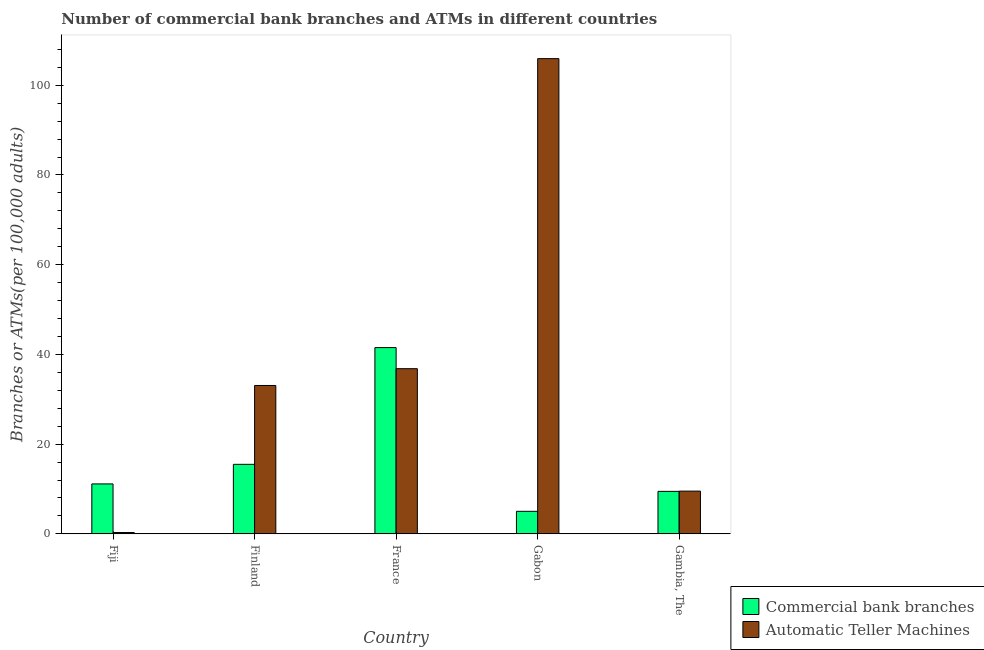How many different coloured bars are there?
Your response must be concise. 2. Are the number of bars on each tick of the X-axis equal?
Your response must be concise. Yes. How many bars are there on the 4th tick from the right?
Offer a very short reply. 2. In how many cases, is the number of bars for a given country not equal to the number of legend labels?
Your answer should be very brief. 0. What is the number of commercal bank branches in Gabon?
Offer a terse response. 5.03. Across all countries, what is the maximum number of atms?
Ensure brevity in your answer.  105.94. Across all countries, what is the minimum number of atms?
Your response must be concise. 0.3. In which country was the number of commercal bank branches minimum?
Provide a succinct answer. Gabon. What is the total number of commercal bank branches in the graph?
Your response must be concise. 82.66. What is the difference between the number of commercal bank branches in Gabon and that in Gambia, The?
Offer a terse response. -4.45. What is the difference between the number of commercal bank branches in Fiji and the number of atms in France?
Make the answer very short. -25.69. What is the average number of atms per country?
Ensure brevity in your answer.  37.13. What is the difference between the number of commercal bank branches and number of atms in Gabon?
Give a very brief answer. -100.91. What is the ratio of the number of atms in Finland to that in Gabon?
Make the answer very short. 0.31. Is the number of commercal bank branches in Fiji less than that in France?
Offer a terse response. Yes. What is the difference between the highest and the second highest number of commercal bank branches?
Provide a succinct answer. 26.03. What is the difference between the highest and the lowest number of atms?
Your answer should be compact. 105.64. Is the sum of the number of atms in Fiji and Gabon greater than the maximum number of commercal bank branches across all countries?
Provide a short and direct response. Yes. What does the 2nd bar from the left in Finland represents?
Your answer should be compact. Automatic Teller Machines. What does the 2nd bar from the right in Finland represents?
Offer a very short reply. Commercial bank branches. How many countries are there in the graph?
Make the answer very short. 5. What is the difference between two consecutive major ticks on the Y-axis?
Give a very brief answer. 20. Are the values on the major ticks of Y-axis written in scientific E-notation?
Provide a short and direct response. No. Does the graph contain any zero values?
Make the answer very short. No. Does the graph contain grids?
Make the answer very short. No. Where does the legend appear in the graph?
Your response must be concise. Bottom right. How many legend labels are there?
Provide a short and direct response. 2. What is the title of the graph?
Offer a very short reply. Number of commercial bank branches and ATMs in different countries. Does "% of GNI" appear as one of the legend labels in the graph?
Provide a succinct answer. No. What is the label or title of the Y-axis?
Keep it short and to the point. Branches or ATMs(per 100,0 adults). What is the Branches or ATMs(per 100,000 adults) in Commercial bank branches in Fiji?
Offer a very short reply. 11.14. What is the Branches or ATMs(per 100,000 adults) of Automatic Teller Machines in Fiji?
Offer a very short reply. 0.3. What is the Branches or ATMs(per 100,000 adults) in Commercial bank branches in Finland?
Ensure brevity in your answer.  15.5. What is the Branches or ATMs(per 100,000 adults) of Automatic Teller Machines in Finland?
Your answer should be compact. 33.08. What is the Branches or ATMs(per 100,000 adults) of Commercial bank branches in France?
Your response must be concise. 41.52. What is the Branches or ATMs(per 100,000 adults) in Automatic Teller Machines in France?
Offer a very short reply. 36.82. What is the Branches or ATMs(per 100,000 adults) in Commercial bank branches in Gabon?
Provide a succinct answer. 5.03. What is the Branches or ATMs(per 100,000 adults) of Automatic Teller Machines in Gabon?
Give a very brief answer. 105.94. What is the Branches or ATMs(per 100,000 adults) of Commercial bank branches in Gambia, The?
Provide a succinct answer. 9.47. What is the Branches or ATMs(per 100,000 adults) in Automatic Teller Machines in Gambia, The?
Make the answer very short. 9.53. Across all countries, what is the maximum Branches or ATMs(per 100,000 adults) of Commercial bank branches?
Your response must be concise. 41.52. Across all countries, what is the maximum Branches or ATMs(per 100,000 adults) of Automatic Teller Machines?
Make the answer very short. 105.94. Across all countries, what is the minimum Branches or ATMs(per 100,000 adults) in Commercial bank branches?
Offer a very short reply. 5.03. Across all countries, what is the minimum Branches or ATMs(per 100,000 adults) of Automatic Teller Machines?
Give a very brief answer. 0.3. What is the total Branches or ATMs(per 100,000 adults) of Commercial bank branches in the graph?
Offer a terse response. 82.66. What is the total Branches or ATMs(per 100,000 adults) in Automatic Teller Machines in the graph?
Give a very brief answer. 185.67. What is the difference between the Branches or ATMs(per 100,000 adults) of Commercial bank branches in Fiji and that in Finland?
Ensure brevity in your answer.  -4.36. What is the difference between the Branches or ATMs(per 100,000 adults) in Automatic Teller Machines in Fiji and that in Finland?
Provide a succinct answer. -32.78. What is the difference between the Branches or ATMs(per 100,000 adults) in Commercial bank branches in Fiji and that in France?
Offer a terse response. -30.39. What is the difference between the Branches or ATMs(per 100,000 adults) of Automatic Teller Machines in Fiji and that in France?
Your answer should be very brief. -36.52. What is the difference between the Branches or ATMs(per 100,000 adults) in Commercial bank branches in Fiji and that in Gabon?
Offer a very short reply. 6.11. What is the difference between the Branches or ATMs(per 100,000 adults) of Automatic Teller Machines in Fiji and that in Gabon?
Keep it short and to the point. -105.64. What is the difference between the Branches or ATMs(per 100,000 adults) of Commercial bank branches in Fiji and that in Gambia, The?
Offer a terse response. 1.66. What is the difference between the Branches or ATMs(per 100,000 adults) in Automatic Teller Machines in Fiji and that in Gambia, The?
Offer a terse response. -9.23. What is the difference between the Branches or ATMs(per 100,000 adults) of Commercial bank branches in Finland and that in France?
Provide a succinct answer. -26.03. What is the difference between the Branches or ATMs(per 100,000 adults) in Automatic Teller Machines in Finland and that in France?
Make the answer very short. -3.75. What is the difference between the Branches or ATMs(per 100,000 adults) in Commercial bank branches in Finland and that in Gabon?
Keep it short and to the point. 10.47. What is the difference between the Branches or ATMs(per 100,000 adults) in Automatic Teller Machines in Finland and that in Gabon?
Your response must be concise. -72.86. What is the difference between the Branches or ATMs(per 100,000 adults) of Commercial bank branches in Finland and that in Gambia, The?
Offer a very short reply. 6.03. What is the difference between the Branches or ATMs(per 100,000 adults) of Automatic Teller Machines in Finland and that in Gambia, The?
Keep it short and to the point. 23.55. What is the difference between the Branches or ATMs(per 100,000 adults) of Commercial bank branches in France and that in Gabon?
Your answer should be compact. 36.5. What is the difference between the Branches or ATMs(per 100,000 adults) in Automatic Teller Machines in France and that in Gabon?
Provide a succinct answer. -69.12. What is the difference between the Branches or ATMs(per 100,000 adults) of Commercial bank branches in France and that in Gambia, The?
Provide a short and direct response. 32.05. What is the difference between the Branches or ATMs(per 100,000 adults) of Automatic Teller Machines in France and that in Gambia, The?
Your answer should be very brief. 27.3. What is the difference between the Branches or ATMs(per 100,000 adults) of Commercial bank branches in Gabon and that in Gambia, The?
Offer a very short reply. -4.45. What is the difference between the Branches or ATMs(per 100,000 adults) in Automatic Teller Machines in Gabon and that in Gambia, The?
Your answer should be very brief. 96.41. What is the difference between the Branches or ATMs(per 100,000 adults) in Commercial bank branches in Fiji and the Branches or ATMs(per 100,000 adults) in Automatic Teller Machines in Finland?
Keep it short and to the point. -21.94. What is the difference between the Branches or ATMs(per 100,000 adults) of Commercial bank branches in Fiji and the Branches or ATMs(per 100,000 adults) of Automatic Teller Machines in France?
Make the answer very short. -25.69. What is the difference between the Branches or ATMs(per 100,000 adults) in Commercial bank branches in Fiji and the Branches or ATMs(per 100,000 adults) in Automatic Teller Machines in Gabon?
Provide a short and direct response. -94.81. What is the difference between the Branches or ATMs(per 100,000 adults) in Commercial bank branches in Fiji and the Branches or ATMs(per 100,000 adults) in Automatic Teller Machines in Gambia, The?
Provide a short and direct response. 1.61. What is the difference between the Branches or ATMs(per 100,000 adults) in Commercial bank branches in Finland and the Branches or ATMs(per 100,000 adults) in Automatic Teller Machines in France?
Give a very brief answer. -21.33. What is the difference between the Branches or ATMs(per 100,000 adults) of Commercial bank branches in Finland and the Branches or ATMs(per 100,000 adults) of Automatic Teller Machines in Gabon?
Offer a terse response. -90.44. What is the difference between the Branches or ATMs(per 100,000 adults) of Commercial bank branches in Finland and the Branches or ATMs(per 100,000 adults) of Automatic Teller Machines in Gambia, The?
Offer a terse response. 5.97. What is the difference between the Branches or ATMs(per 100,000 adults) of Commercial bank branches in France and the Branches or ATMs(per 100,000 adults) of Automatic Teller Machines in Gabon?
Your response must be concise. -64.42. What is the difference between the Branches or ATMs(per 100,000 adults) in Commercial bank branches in France and the Branches or ATMs(per 100,000 adults) in Automatic Teller Machines in Gambia, The?
Keep it short and to the point. 32. What is the difference between the Branches or ATMs(per 100,000 adults) of Commercial bank branches in Gabon and the Branches or ATMs(per 100,000 adults) of Automatic Teller Machines in Gambia, The?
Provide a short and direct response. -4.5. What is the average Branches or ATMs(per 100,000 adults) in Commercial bank branches per country?
Offer a terse response. 16.53. What is the average Branches or ATMs(per 100,000 adults) of Automatic Teller Machines per country?
Provide a short and direct response. 37.13. What is the difference between the Branches or ATMs(per 100,000 adults) in Commercial bank branches and Branches or ATMs(per 100,000 adults) in Automatic Teller Machines in Fiji?
Provide a short and direct response. 10.84. What is the difference between the Branches or ATMs(per 100,000 adults) in Commercial bank branches and Branches or ATMs(per 100,000 adults) in Automatic Teller Machines in Finland?
Offer a very short reply. -17.58. What is the difference between the Branches or ATMs(per 100,000 adults) in Commercial bank branches and Branches or ATMs(per 100,000 adults) in Automatic Teller Machines in France?
Ensure brevity in your answer.  4.7. What is the difference between the Branches or ATMs(per 100,000 adults) in Commercial bank branches and Branches or ATMs(per 100,000 adults) in Automatic Teller Machines in Gabon?
Your answer should be compact. -100.91. What is the difference between the Branches or ATMs(per 100,000 adults) of Commercial bank branches and Branches or ATMs(per 100,000 adults) of Automatic Teller Machines in Gambia, The?
Offer a terse response. -0.06. What is the ratio of the Branches or ATMs(per 100,000 adults) of Commercial bank branches in Fiji to that in Finland?
Offer a terse response. 0.72. What is the ratio of the Branches or ATMs(per 100,000 adults) of Automatic Teller Machines in Fiji to that in Finland?
Make the answer very short. 0.01. What is the ratio of the Branches or ATMs(per 100,000 adults) in Commercial bank branches in Fiji to that in France?
Provide a succinct answer. 0.27. What is the ratio of the Branches or ATMs(per 100,000 adults) of Automatic Teller Machines in Fiji to that in France?
Offer a very short reply. 0.01. What is the ratio of the Branches or ATMs(per 100,000 adults) in Commercial bank branches in Fiji to that in Gabon?
Keep it short and to the point. 2.22. What is the ratio of the Branches or ATMs(per 100,000 adults) in Automatic Teller Machines in Fiji to that in Gabon?
Make the answer very short. 0. What is the ratio of the Branches or ATMs(per 100,000 adults) in Commercial bank branches in Fiji to that in Gambia, The?
Provide a short and direct response. 1.18. What is the ratio of the Branches or ATMs(per 100,000 adults) of Automatic Teller Machines in Fiji to that in Gambia, The?
Keep it short and to the point. 0.03. What is the ratio of the Branches or ATMs(per 100,000 adults) in Commercial bank branches in Finland to that in France?
Offer a very short reply. 0.37. What is the ratio of the Branches or ATMs(per 100,000 adults) of Automatic Teller Machines in Finland to that in France?
Your answer should be compact. 0.9. What is the ratio of the Branches or ATMs(per 100,000 adults) in Commercial bank branches in Finland to that in Gabon?
Your answer should be very brief. 3.08. What is the ratio of the Branches or ATMs(per 100,000 adults) of Automatic Teller Machines in Finland to that in Gabon?
Provide a succinct answer. 0.31. What is the ratio of the Branches or ATMs(per 100,000 adults) of Commercial bank branches in Finland to that in Gambia, The?
Give a very brief answer. 1.64. What is the ratio of the Branches or ATMs(per 100,000 adults) in Automatic Teller Machines in Finland to that in Gambia, The?
Your answer should be compact. 3.47. What is the ratio of the Branches or ATMs(per 100,000 adults) in Commercial bank branches in France to that in Gabon?
Give a very brief answer. 8.26. What is the ratio of the Branches or ATMs(per 100,000 adults) of Automatic Teller Machines in France to that in Gabon?
Give a very brief answer. 0.35. What is the ratio of the Branches or ATMs(per 100,000 adults) in Commercial bank branches in France to that in Gambia, The?
Offer a very short reply. 4.38. What is the ratio of the Branches or ATMs(per 100,000 adults) of Automatic Teller Machines in France to that in Gambia, The?
Ensure brevity in your answer.  3.86. What is the ratio of the Branches or ATMs(per 100,000 adults) of Commercial bank branches in Gabon to that in Gambia, The?
Provide a short and direct response. 0.53. What is the ratio of the Branches or ATMs(per 100,000 adults) of Automatic Teller Machines in Gabon to that in Gambia, The?
Give a very brief answer. 11.12. What is the difference between the highest and the second highest Branches or ATMs(per 100,000 adults) of Commercial bank branches?
Offer a very short reply. 26.03. What is the difference between the highest and the second highest Branches or ATMs(per 100,000 adults) in Automatic Teller Machines?
Make the answer very short. 69.12. What is the difference between the highest and the lowest Branches or ATMs(per 100,000 adults) of Commercial bank branches?
Provide a short and direct response. 36.5. What is the difference between the highest and the lowest Branches or ATMs(per 100,000 adults) of Automatic Teller Machines?
Offer a very short reply. 105.64. 